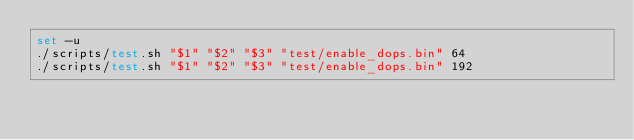Convert code to text. <code><loc_0><loc_0><loc_500><loc_500><_Bash_>set -u
./scripts/test.sh "$1" "$2" "$3" "test/enable_dops.bin" 64
./scripts/test.sh "$1" "$2" "$3" "test/enable_dops.bin" 192
</code> 